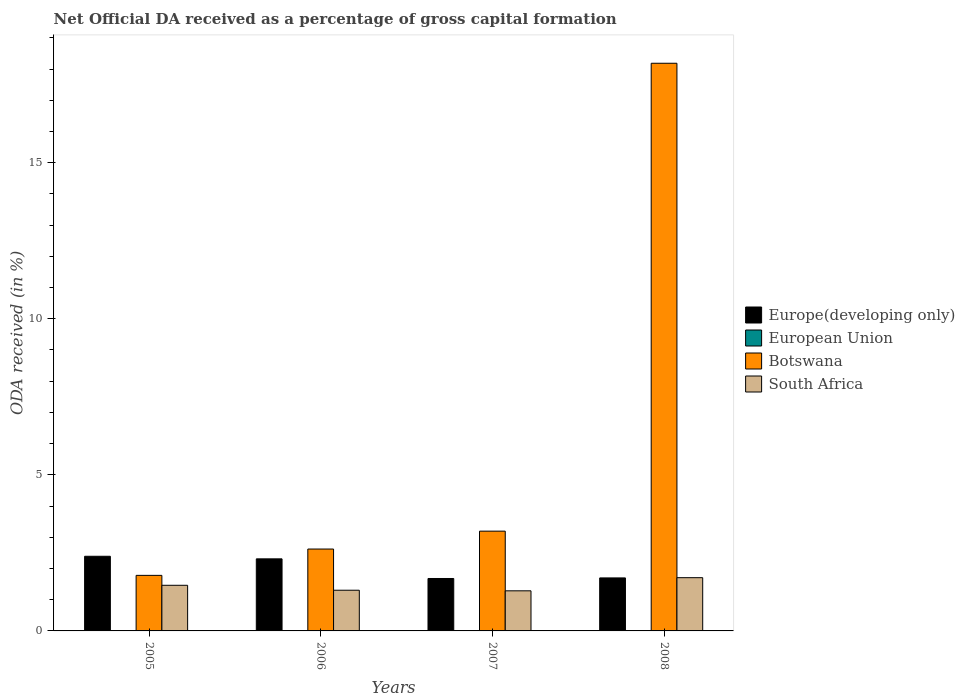How many different coloured bars are there?
Your answer should be compact. 4. Are the number of bars per tick equal to the number of legend labels?
Keep it short and to the point. Yes. How many bars are there on the 3rd tick from the left?
Offer a very short reply. 4. What is the label of the 1st group of bars from the left?
Offer a terse response. 2005. What is the net ODA received in European Union in 2006?
Make the answer very short. 0.01. Across all years, what is the maximum net ODA received in European Union?
Offer a very short reply. 0.01. Across all years, what is the minimum net ODA received in Europe(developing only)?
Your answer should be compact. 1.68. In which year was the net ODA received in South Africa maximum?
Your answer should be very brief. 2008. What is the total net ODA received in European Union in the graph?
Offer a terse response. 0.02. What is the difference between the net ODA received in Botswana in 2005 and that in 2006?
Ensure brevity in your answer.  -0.84. What is the difference between the net ODA received in Europe(developing only) in 2007 and the net ODA received in Botswana in 2005?
Offer a terse response. -0.1. What is the average net ODA received in Botswana per year?
Ensure brevity in your answer.  6.45. In the year 2006, what is the difference between the net ODA received in European Union and net ODA received in Europe(developing only)?
Provide a succinct answer. -2.3. What is the ratio of the net ODA received in Europe(developing only) in 2005 to that in 2006?
Your response must be concise. 1.04. Is the difference between the net ODA received in European Union in 2007 and 2008 greater than the difference between the net ODA received in Europe(developing only) in 2007 and 2008?
Offer a terse response. Yes. What is the difference between the highest and the second highest net ODA received in European Union?
Ensure brevity in your answer.  0. What is the difference between the highest and the lowest net ODA received in Botswana?
Your response must be concise. 16.41. In how many years, is the net ODA received in Europe(developing only) greater than the average net ODA received in Europe(developing only) taken over all years?
Your response must be concise. 2. Is the sum of the net ODA received in South Africa in 2005 and 2007 greater than the maximum net ODA received in Europe(developing only) across all years?
Your answer should be very brief. Yes. Is it the case that in every year, the sum of the net ODA received in Europe(developing only) and net ODA received in European Union is greater than the sum of net ODA received in South Africa and net ODA received in Botswana?
Make the answer very short. No. What does the 1st bar from the left in 2007 represents?
Your answer should be very brief. Europe(developing only). What does the 4th bar from the right in 2006 represents?
Provide a succinct answer. Europe(developing only). Are all the bars in the graph horizontal?
Give a very brief answer. No. Are the values on the major ticks of Y-axis written in scientific E-notation?
Your answer should be very brief. No. Where does the legend appear in the graph?
Provide a short and direct response. Center right. What is the title of the graph?
Give a very brief answer. Net Official DA received as a percentage of gross capital formation. Does "Puerto Rico" appear as one of the legend labels in the graph?
Offer a very short reply. No. What is the label or title of the Y-axis?
Offer a very short reply. ODA received (in %). What is the ODA received (in %) of Europe(developing only) in 2005?
Provide a succinct answer. 2.39. What is the ODA received (in %) in European Union in 2005?
Your response must be concise. 0. What is the ODA received (in %) of Botswana in 2005?
Your response must be concise. 1.78. What is the ODA received (in %) of South Africa in 2005?
Your answer should be compact. 1.46. What is the ODA received (in %) of Europe(developing only) in 2006?
Your answer should be very brief. 2.31. What is the ODA received (in %) in European Union in 2006?
Your answer should be compact. 0.01. What is the ODA received (in %) in Botswana in 2006?
Your answer should be compact. 2.62. What is the ODA received (in %) of South Africa in 2006?
Keep it short and to the point. 1.3. What is the ODA received (in %) in Europe(developing only) in 2007?
Make the answer very short. 1.68. What is the ODA received (in %) of European Union in 2007?
Keep it short and to the point. 0. What is the ODA received (in %) in Botswana in 2007?
Offer a very short reply. 3.2. What is the ODA received (in %) of South Africa in 2007?
Your response must be concise. 1.28. What is the ODA received (in %) of Europe(developing only) in 2008?
Provide a succinct answer. 1.7. What is the ODA received (in %) in European Union in 2008?
Your answer should be compact. 0.01. What is the ODA received (in %) in Botswana in 2008?
Your response must be concise. 18.19. What is the ODA received (in %) of South Africa in 2008?
Offer a very short reply. 1.71. Across all years, what is the maximum ODA received (in %) in Europe(developing only)?
Offer a very short reply. 2.39. Across all years, what is the maximum ODA received (in %) of European Union?
Offer a terse response. 0.01. Across all years, what is the maximum ODA received (in %) of Botswana?
Make the answer very short. 18.19. Across all years, what is the maximum ODA received (in %) of South Africa?
Ensure brevity in your answer.  1.71. Across all years, what is the minimum ODA received (in %) in Europe(developing only)?
Provide a succinct answer. 1.68. Across all years, what is the minimum ODA received (in %) in European Union?
Your answer should be very brief. 0. Across all years, what is the minimum ODA received (in %) in Botswana?
Offer a very short reply. 1.78. Across all years, what is the minimum ODA received (in %) of South Africa?
Offer a very short reply. 1.28. What is the total ODA received (in %) of Europe(developing only) in the graph?
Offer a terse response. 8.08. What is the total ODA received (in %) in European Union in the graph?
Keep it short and to the point. 0.02. What is the total ODA received (in %) in Botswana in the graph?
Give a very brief answer. 25.78. What is the total ODA received (in %) of South Africa in the graph?
Offer a very short reply. 5.76. What is the difference between the ODA received (in %) in Europe(developing only) in 2005 and that in 2006?
Your answer should be compact. 0.08. What is the difference between the ODA received (in %) of European Union in 2005 and that in 2006?
Keep it short and to the point. -0. What is the difference between the ODA received (in %) in Botswana in 2005 and that in 2006?
Your answer should be very brief. -0.84. What is the difference between the ODA received (in %) of South Africa in 2005 and that in 2006?
Provide a short and direct response. 0.16. What is the difference between the ODA received (in %) of Europe(developing only) in 2005 and that in 2007?
Offer a terse response. 0.71. What is the difference between the ODA received (in %) of European Union in 2005 and that in 2007?
Keep it short and to the point. 0. What is the difference between the ODA received (in %) of Botswana in 2005 and that in 2007?
Offer a terse response. -1.42. What is the difference between the ODA received (in %) in South Africa in 2005 and that in 2007?
Provide a succinct answer. 0.18. What is the difference between the ODA received (in %) of Europe(developing only) in 2005 and that in 2008?
Make the answer very short. 0.69. What is the difference between the ODA received (in %) of European Union in 2005 and that in 2008?
Make the answer very short. -0. What is the difference between the ODA received (in %) of Botswana in 2005 and that in 2008?
Offer a terse response. -16.41. What is the difference between the ODA received (in %) of South Africa in 2005 and that in 2008?
Your answer should be compact. -0.24. What is the difference between the ODA received (in %) in Europe(developing only) in 2006 and that in 2007?
Your answer should be compact. 0.63. What is the difference between the ODA received (in %) of European Union in 2006 and that in 2007?
Offer a very short reply. 0. What is the difference between the ODA received (in %) in Botswana in 2006 and that in 2007?
Provide a succinct answer. -0.57. What is the difference between the ODA received (in %) in South Africa in 2006 and that in 2007?
Your answer should be compact. 0.02. What is the difference between the ODA received (in %) in Europe(developing only) in 2006 and that in 2008?
Offer a terse response. 0.61. What is the difference between the ODA received (in %) in Botswana in 2006 and that in 2008?
Provide a succinct answer. -15.56. What is the difference between the ODA received (in %) of South Africa in 2006 and that in 2008?
Ensure brevity in your answer.  -0.4. What is the difference between the ODA received (in %) in Europe(developing only) in 2007 and that in 2008?
Your response must be concise. -0.02. What is the difference between the ODA received (in %) in European Union in 2007 and that in 2008?
Offer a very short reply. -0. What is the difference between the ODA received (in %) of Botswana in 2007 and that in 2008?
Offer a terse response. -14.99. What is the difference between the ODA received (in %) in South Africa in 2007 and that in 2008?
Keep it short and to the point. -0.42. What is the difference between the ODA received (in %) of Europe(developing only) in 2005 and the ODA received (in %) of European Union in 2006?
Ensure brevity in your answer.  2.39. What is the difference between the ODA received (in %) in Europe(developing only) in 2005 and the ODA received (in %) in Botswana in 2006?
Offer a terse response. -0.23. What is the difference between the ODA received (in %) in Europe(developing only) in 2005 and the ODA received (in %) in South Africa in 2006?
Keep it short and to the point. 1.09. What is the difference between the ODA received (in %) in European Union in 2005 and the ODA received (in %) in Botswana in 2006?
Provide a succinct answer. -2.62. What is the difference between the ODA received (in %) of European Union in 2005 and the ODA received (in %) of South Africa in 2006?
Offer a terse response. -1.3. What is the difference between the ODA received (in %) of Botswana in 2005 and the ODA received (in %) of South Africa in 2006?
Your response must be concise. 0.48. What is the difference between the ODA received (in %) in Europe(developing only) in 2005 and the ODA received (in %) in European Union in 2007?
Provide a short and direct response. 2.39. What is the difference between the ODA received (in %) in Europe(developing only) in 2005 and the ODA received (in %) in Botswana in 2007?
Make the answer very short. -0.81. What is the difference between the ODA received (in %) of Europe(developing only) in 2005 and the ODA received (in %) of South Africa in 2007?
Ensure brevity in your answer.  1.11. What is the difference between the ODA received (in %) in European Union in 2005 and the ODA received (in %) in Botswana in 2007?
Make the answer very short. -3.19. What is the difference between the ODA received (in %) of European Union in 2005 and the ODA received (in %) of South Africa in 2007?
Your answer should be very brief. -1.28. What is the difference between the ODA received (in %) of Botswana in 2005 and the ODA received (in %) of South Africa in 2007?
Provide a succinct answer. 0.49. What is the difference between the ODA received (in %) in Europe(developing only) in 2005 and the ODA received (in %) in European Union in 2008?
Your answer should be very brief. 2.39. What is the difference between the ODA received (in %) in Europe(developing only) in 2005 and the ODA received (in %) in Botswana in 2008?
Keep it short and to the point. -15.79. What is the difference between the ODA received (in %) in Europe(developing only) in 2005 and the ODA received (in %) in South Africa in 2008?
Provide a succinct answer. 0.69. What is the difference between the ODA received (in %) in European Union in 2005 and the ODA received (in %) in Botswana in 2008?
Give a very brief answer. -18.18. What is the difference between the ODA received (in %) in European Union in 2005 and the ODA received (in %) in South Africa in 2008?
Provide a succinct answer. -1.7. What is the difference between the ODA received (in %) of Botswana in 2005 and the ODA received (in %) of South Africa in 2008?
Your answer should be compact. 0.07. What is the difference between the ODA received (in %) in Europe(developing only) in 2006 and the ODA received (in %) in European Union in 2007?
Make the answer very short. 2.31. What is the difference between the ODA received (in %) in Europe(developing only) in 2006 and the ODA received (in %) in Botswana in 2007?
Your answer should be compact. -0.89. What is the difference between the ODA received (in %) in Europe(developing only) in 2006 and the ODA received (in %) in South Africa in 2007?
Your answer should be very brief. 1.02. What is the difference between the ODA received (in %) of European Union in 2006 and the ODA received (in %) of Botswana in 2007?
Your answer should be compact. -3.19. What is the difference between the ODA received (in %) of European Union in 2006 and the ODA received (in %) of South Africa in 2007?
Your response must be concise. -1.28. What is the difference between the ODA received (in %) in Botswana in 2006 and the ODA received (in %) in South Africa in 2007?
Ensure brevity in your answer.  1.34. What is the difference between the ODA received (in %) of Europe(developing only) in 2006 and the ODA received (in %) of European Union in 2008?
Keep it short and to the point. 2.3. What is the difference between the ODA received (in %) in Europe(developing only) in 2006 and the ODA received (in %) in Botswana in 2008?
Ensure brevity in your answer.  -15.88. What is the difference between the ODA received (in %) of Europe(developing only) in 2006 and the ODA received (in %) of South Africa in 2008?
Make the answer very short. 0.6. What is the difference between the ODA received (in %) of European Union in 2006 and the ODA received (in %) of Botswana in 2008?
Give a very brief answer. -18.18. What is the difference between the ODA received (in %) of European Union in 2006 and the ODA received (in %) of South Africa in 2008?
Make the answer very short. -1.7. What is the difference between the ODA received (in %) in Botswana in 2006 and the ODA received (in %) in South Africa in 2008?
Make the answer very short. 0.92. What is the difference between the ODA received (in %) of Europe(developing only) in 2007 and the ODA received (in %) of European Union in 2008?
Your response must be concise. 1.67. What is the difference between the ODA received (in %) of Europe(developing only) in 2007 and the ODA received (in %) of Botswana in 2008?
Offer a very short reply. -16.51. What is the difference between the ODA received (in %) of Europe(developing only) in 2007 and the ODA received (in %) of South Africa in 2008?
Provide a short and direct response. -0.03. What is the difference between the ODA received (in %) of European Union in 2007 and the ODA received (in %) of Botswana in 2008?
Keep it short and to the point. -18.18. What is the difference between the ODA received (in %) in European Union in 2007 and the ODA received (in %) in South Africa in 2008?
Give a very brief answer. -1.7. What is the difference between the ODA received (in %) of Botswana in 2007 and the ODA received (in %) of South Africa in 2008?
Keep it short and to the point. 1.49. What is the average ODA received (in %) of Europe(developing only) per year?
Your response must be concise. 2.02. What is the average ODA received (in %) in European Union per year?
Your answer should be very brief. 0. What is the average ODA received (in %) in Botswana per year?
Keep it short and to the point. 6.45. What is the average ODA received (in %) of South Africa per year?
Your response must be concise. 1.44. In the year 2005, what is the difference between the ODA received (in %) in Europe(developing only) and ODA received (in %) in European Union?
Your response must be concise. 2.39. In the year 2005, what is the difference between the ODA received (in %) of Europe(developing only) and ODA received (in %) of Botswana?
Provide a succinct answer. 0.61. In the year 2005, what is the difference between the ODA received (in %) of Europe(developing only) and ODA received (in %) of South Africa?
Your answer should be very brief. 0.93. In the year 2005, what is the difference between the ODA received (in %) of European Union and ODA received (in %) of Botswana?
Provide a succinct answer. -1.78. In the year 2005, what is the difference between the ODA received (in %) of European Union and ODA received (in %) of South Africa?
Your answer should be compact. -1.46. In the year 2005, what is the difference between the ODA received (in %) in Botswana and ODA received (in %) in South Africa?
Your answer should be compact. 0.32. In the year 2006, what is the difference between the ODA received (in %) in Europe(developing only) and ODA received (in %) in European Union?
Ensure brevity in your answer.  2.3. In the year 2006, what is the difference between the ODA received (in %) in Europe(developing only) and ODA received (in %) in Botswana?
Your answer should be compact. -0.31. In the year 2006, what is the difference between the ODA received (in %) of European Union and ODA received (in %) of Botswana?
Your response must be concise. -2.62. In the year 2006, what is the difference between the ODA received (in %) of European Union and ODA received (in %) of South Africa?
Provide a succinct answer. -1.3. In the year 2006, what is the difference between the ODA received (in %) of Botswana and ODA received (in %) of South Africa?
Your response must be concise. 1.32. In the year 2007, what is the difference between the ODA received (in %) in Europe(developing only) and ODA received (in %) in European Union?
Your response must be concise. 1.68. In the year 2007, what is the difference between the ODA received (in %) in Europe(developing only) and ODA received (in %) in Botswana?
Make the answer very short. -1.52. In the year 2007, what is the difference between the ODA received (in %) in Europe(developing only) and ODA received (in %) in South Africa?
Offer a terse response. 0.4. In the year 2007, what is the difference between the ODA received (in %) of European Union and ODA received (in %) of Botswana?
Keep it short and to the point. -3.19. In the year 2007, what is the difference between the ODA received (in %) of European Union and ODA received (in %) of South Africa?
Ensure brevity in your answer.  -1.28. In the year 2007, what is the difference between the ODA received (in %) in Botswana and ODA received (in %) in South Africa?
Offer a terse response. 1.91. In the year 2008, what is the difference between the ODA received (in %) in Europe(developing only) and ODA received (in %) in European Union?
Keep it short and to the point. 1.69. In the year 2008, what is the difference between the ODA received (in %) of Europe(developing only) and ODA received (in %) of Botswana?
Your answer should be very brief. -16.49. In the year 2008, what is the difference between the ODA received (in %) of Europe(developing only) and ODA received (in %) of South Africa?
Your answer should be compact. -0.01. In the year 2008, what is the difference between the ODA received (in %) in European Union and ODA received (in %) in Botswana?
Provide a succinct answer. -18.18. In the year 2008, what is the difference between the ODA received (in %) in Botswana and ODA received (in %) in South Africa?
Your answer should be compact. 16.48. What is the ratio of the ODA received (in %) of Europe(developing only) in 2005 to that in 2006?
Ensure brevity in your answer.  1.04. What is the ratio of the ODA received (in %) of European Union in 2005 to that in 2006?
Give a very brief answer. 0.67. What is the ratio of the ODA received (in %) in Botswana in 2005 to that in 2006?
Offer a terse response. 0.68. What is the ratio of the ODA received (in %) of South Africa in 2005 to that in 2006?
Your response must be concise. 1.12. What is the ratio of the ODA received (in %) in Europe(developing only) in 2005 to that in 2007?
Ensure brevity in your answer.  1.42. What is the ratio of the ODA received (in %) of European Union in 2005 to that in 2007?
Give a very brief answer. 1.01. What is the ratio of the ODA received (in %) in Botswana in 2005 to that in 2007?
Offer a terse response. 0.56. What is the ratio of the ODA received (in %) of South Africa in 2005 to that in 2007?
Ensure brevity in your answer.  1.14. What is the ratio of the ODA received (in %) in Europe(developing only) in 2005 to that in 2008?
Your answer should be very brief. 1.41. What is the ratio of the ODA received (in %) in European Union in 2005 to that in 2008?
Make the answer very short. 0.72. What is the ratio of the ODA received (in %) of Botswana in 2005 to that in 2008?
Your answer should be compact. 0.1. What is the ratio of the ODA received (in %) in South Africa in 2005 to that in 2008?
Keep it short and to the point. 0.86. What is the ratio of the ODA received (in %) in Europe(developing only) in 2006 to that in 2007?
Your response must be concise. 1.37. What is the ratio of the ODA received (in %) in European Union in 2006 to that in 2007?
Ensure brevity in your answer.  1.5. What is the ratio of the ODA received (in %) of Botswana in 2006 to that in 2007?
Offer a terse response. 0.82. What is the ratio of the ODA received (in %) of South Africa in 2006 to that in 2007?
Offer a terse response. 1.01. What is the ratio of the ODA received (in %) in Europe(developing only) in 2006 to that in 2008?
Your answer should be compact. 1.36. What is the ratio of the ODA received (in %) of European Union in 2006 to that in 2008?
Your answer should be very brief. 1.07. What is the ratio of the ODA received (in %) of Botswana in 2006 to that in 2008?
Keep it short and to the point. 0.14. What is the ratio of the ODA received (in %) in South Africa in 2006 to that in 2008?
Provide a short and direct response. 0.76. What is the ratio of the ODA received (in %) in European Union in 2007 to that in 2008?
Offer a terse response. 0.72. What is the ratio of the ODA received (in %) in Botswana in 2007 to that in 2008?
Your response must be concise. 0.18. What is the ratio of the ODA received (in %) of South Africa in 2007 to that in 2008?
Give a very brief answer. 0.75. What is the difference between the highest and the second highest ODA received (in %) of Europe(developing only)?
Provide a short and direct response. 0.08. What is the difference between the highest and the second highest ODA received (in %) of Botswana?
Provide a short and direct response. 14.99. What is the difference between the highest and the second highest ODA received (in %) of South Africa?
Your answer should be very brief. 0.24. What is the difference between the highest and the lowest ODA received (in %) in Europe(developing only)?
Keep it short and to the point. 0.71. What is the difference between the highest and the lowest ODA received (in %) in European Union?
Provide a succinct answer. 0. What is the difference between the highest and the lowest ODA received (in %) of Botswana?
Give a very brief answer. 16.41. What is the difference between the highest and the lowest ODA received (in %) of South Africa?
Make the answer very short. 0.42. 